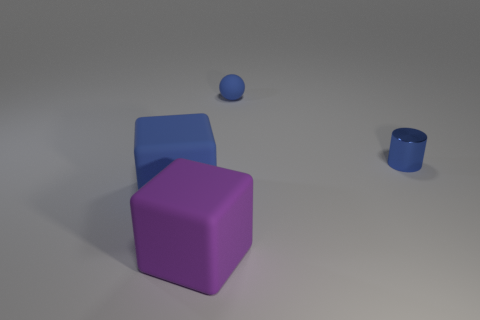What time of day does the lighting in the image suggest? The lighting in the image is diffuse and does not cast strong shadows, suggesting an overcast day or an indoor environment with soft artificial lighting. Does the lighting affect the appearance of the objects' colors? Yes, the soft lighting provides an even illumination across the objects, which helps to maintain their true colors without creating harsh highlights or deep shadows that might alter their perceived hues. 